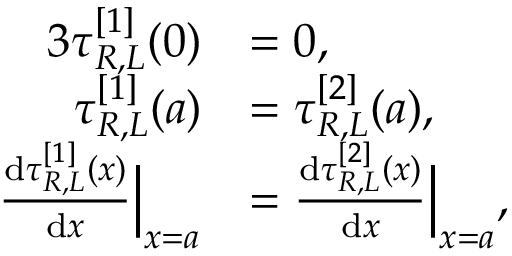<formula> <loc_0><loc_0><loc_500><loc_500>\begin{array} { r l } { { 3 } \tau _ { R , L } ^ { [ 1 ] } ( 0 ) } & { = 0 , } \\ { \tau _ { R , L } ^ { [ 1 ] } ( a ) } & { = \tau _ { R , L } ^ { [ 2 ] } ( a ) , } \\ { \frac { d \tau _ { R , L } ^ { [ 1 ] } ( x ) } { d x } \left | _ { x = a } } & { = \frac { d \tau _ { R , L } ^ { [ 2 ] } ( x ) } { d x } \right | _ { x = a } , } \end{array}</formula> 